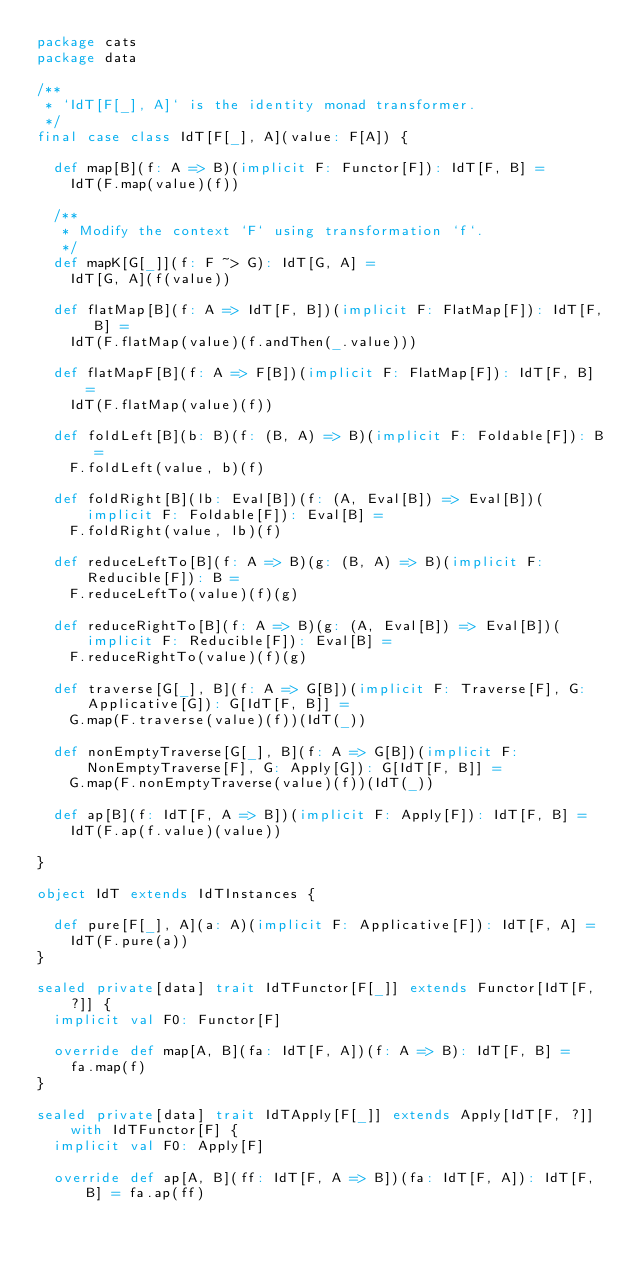Convert code to text. <code><loc_0><loc_0><loc_500><loc_500><_Scala_>package cats
package data

/**
 * `IdT[F[_], A]` is the identity monad transformer.
 */
final case class IdT[F[_], A](value: F[A]) {

  def map[B](f: A => B)(implicit F: Functor[F]): IdT[F, B] =
    IdT(F.map(value)(f))

  /**
   * Modify the context `F` using transformation `f`.
   */
  def mapK[G[_]](f: F ~> G): IdT[G, A] =
    IdT[G, A](f(value))

  def flatMap[B](f: A => IdT[F, B])(implicit F: FlatMap[F]): IdT[F, B] =
    IdT(F.flatMap(value)(f.andThen(_.value)))

  def flatMapF[B](f: A => F[B])(implicit F: FlatMap[F]): IdT[F, B] =
    IdT(F.flatMap(value)(f))

  def foldLeft[B](b: B)(f: (B, A) => B)(implicit F: Foldable[F]): B =
    F.foldLeft(value, b)(f)

  def foldRight[B](lb: Eval[B])(f: (A, Eval[B]) => Eval[B])(implicit F: Foldable[F]): Eval[B] =
    F.foldRight(value, lb)(f)

  def reduceLeftTo[B](f: A => B)(g: (B, A) => B)(implicit F: Reducible[F]): B =
    F.reduceLeftTo(value)(f)(g)

  def reduceRightTo[B](f: A => B)(g: (A, Eval[B]) => Eval[B])(implicit F: Reducible[F]): Eval[B] =
    F.reduceRightTo(value)(f)(g)

  def traverse[G[_], B](f: A => G[B])(implicit F: Traverse[F], G: Applicative[G]): G[IdT[F, B]] =
    G.map(F.traverse(value)(f))(IdT(_))

  def nonEmptyTraverse[G[_], B](f: A => G[B])(implicit F: NonEmptyTraverse[F], G: Apply[G]): G[IdT[F, B]] =
    G.map(F.nonEmptyTraverse(value)(f))(IdT(_))

  def ap[B](f: IdT[F, A => B])(implicit F: Apply[F]): IdT[F, B] =
    IdT(F.ap(f.value)(value))

}

object IdT extends IdTInstances {

  def pure[F[_], A](a: A)(implicit F: Applicative[F]): IdT[F, A] =
    IdT(F.pure(a))
}

sealed private[data] trait IdTFunctor[F[_]] extends Functor[IdT[F, ?]] {
  implicit val F0: Functor[F]

  override def map[A, B](fa: IdT[F, A])(f: A => B): IdT[F, B] =
    fa.map(f)
}

sealed private[data] trait IdTApply[F[_]] extends Apply[IdT[F, ?]] with IdTFunctor[F] {
  implicit val F0: Apply[F]

  override def ap[A, B](ff: IdT[F, A => B])(fa: IdT[F, A]): IdT[F, B] = fa.ap(ff)
</code> 